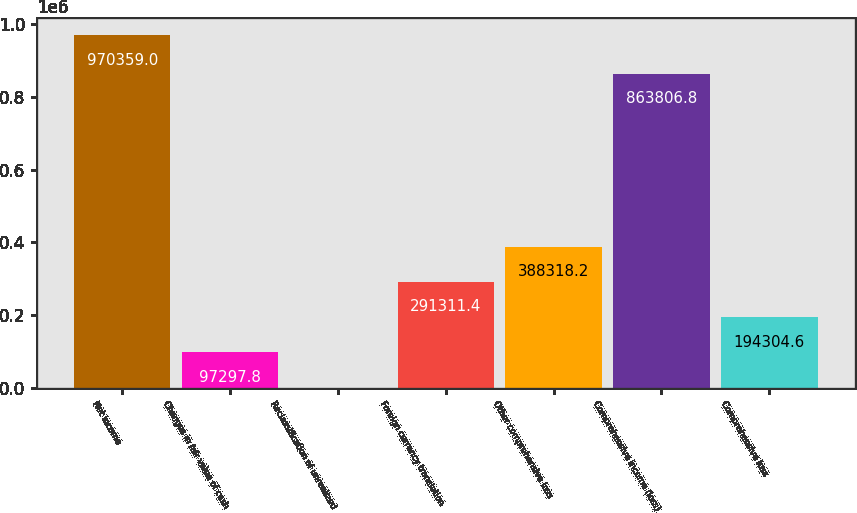Convert chart. <chart><loc_0><loc_0><loc_500><loc_500><bar_chart><fcel>Net income<fcel>Changes in fair value of cash<fcel>Reclassification of unrealized<fcel>Foreign currency translation<fcel>Other comprehensive loss<fcel>Comprehensive income (loss)<fcel>Comprehensive loss<nl><fcel>970359<fcel>97297.8<fcel>291<fcel>291311<fcel>388318<fcel>863807<fcel>194305<nl></chart> 